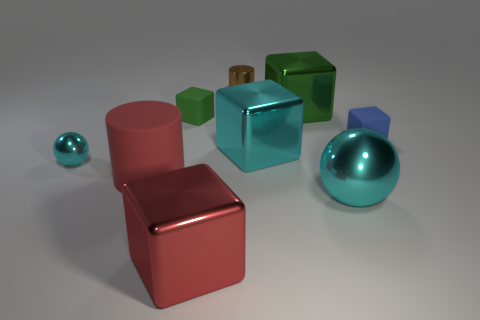Does the rubber cylinder have the same size as the shiny ball to the left of the large rubber cylinder?
Your response must be concise. No. How many metallic things are either small blue cubes or small red cubes?
Offer a very short reply. 0. Is there anything else that has the same material as the small cyan thing?
Offer a very short reply. Yes. There is a rubber cylinder; does it have the same color as the metallic ball that is left of the tiny brown metallic thing?
Provide a succinct answer. No. There is a green rubber object; what shape is it?
Make the answer very short. Cube. There is a sphere that is in front of the cyan metallic sphere that is behind the red thing left of the red cube; how big is it?
Your response must be concise. Large. What number of other objects are there of the same shape as the small green rubber thing?
Keep it short and to the point. 4. There is a metallic thing left of the large cylinder; does it have the same shape as the green metal object that is on the left side of the big cyan metallic sphere?
Keep it short and to the point. No. How many balls are either gray things or blue things?
Your answer should be very brief. 0. What is the material of the large block in front of the shiny object that is to the left of the rubber thing in front of the tiny cyan metallic thing?
Your answer should be compact. Metal. 